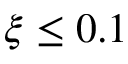Convert formula to latex. <formula><loc_0><loc_0><loc_500><loc_500>\xi \leq 0 . 1</formula> 